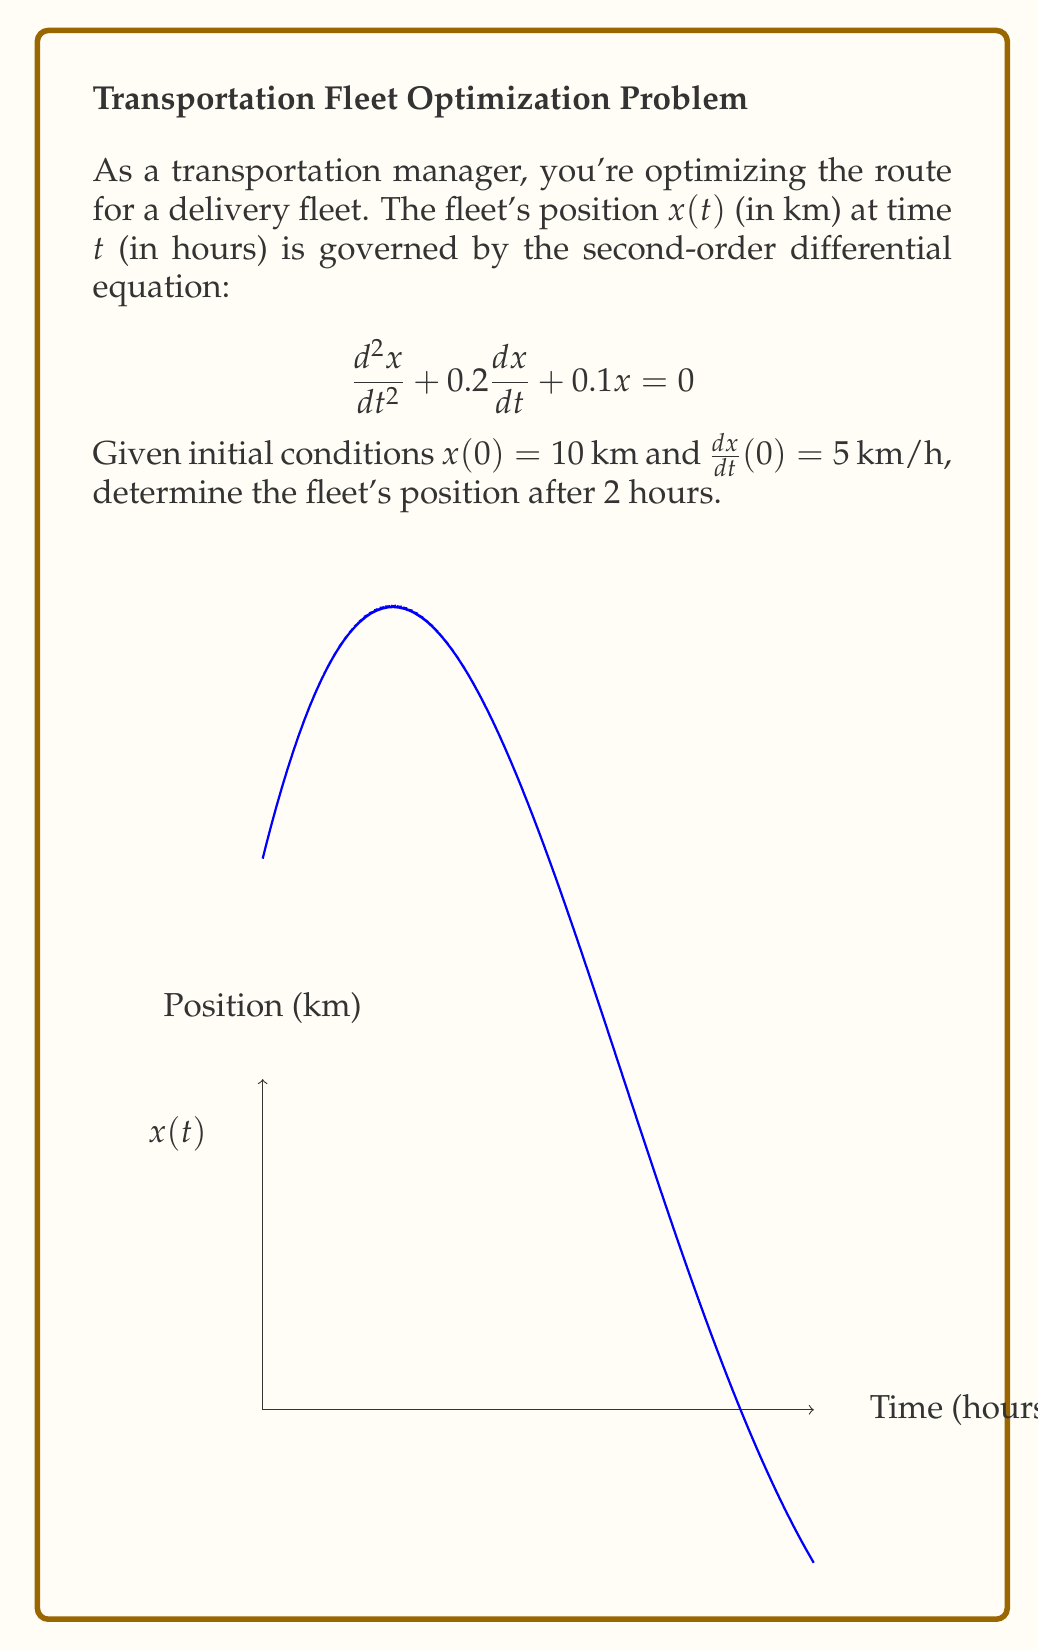Give your solution to this math problem. 1) The general solution for this second-order linear differential equation is:
   $$x(t) = e^{-rt}(A\cos(\omega t) + B\sin(\omega t))$$
   where $r = 0.1$ and $\omega = \sqrt{0.1 - r^2} = 0.3$

2) Using the initial conditions:
   $x(0) = 10$ gives $A = 10$
   $\frac{dx}{dt}(0) = 5$ gives $-rA + \omega B = 5$, so $B = \frac{5 + rA}{\omega} = \frac{50}{3}$

3) Therefore, the particular solution is:
   $$x(t) = 10e^{-0.1t}(\cos(0.3t) + \frac{5}{3}\sin(0.3t))$$

4) To find the position after 2 hours, calculate $x(2)$:
   $$x(2) = 10e^{-0.2}(\cos(0.6) + \frac{5}{3}\sin(0.6))$$

5) Evaluating this expression:
   $$x(2) \approx 13.95 \text{ km}$$
Answer: 13.95 km 